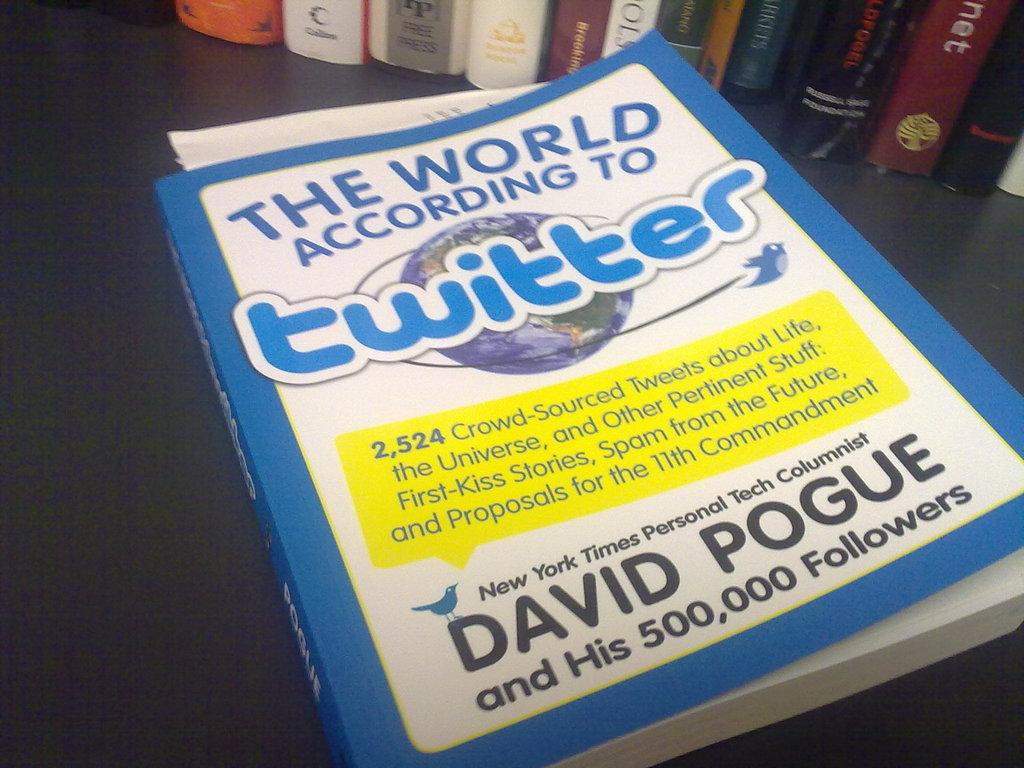<image>
Share a concise interpretation of the image provided. Book about the world according to twiiter by David Pogue 